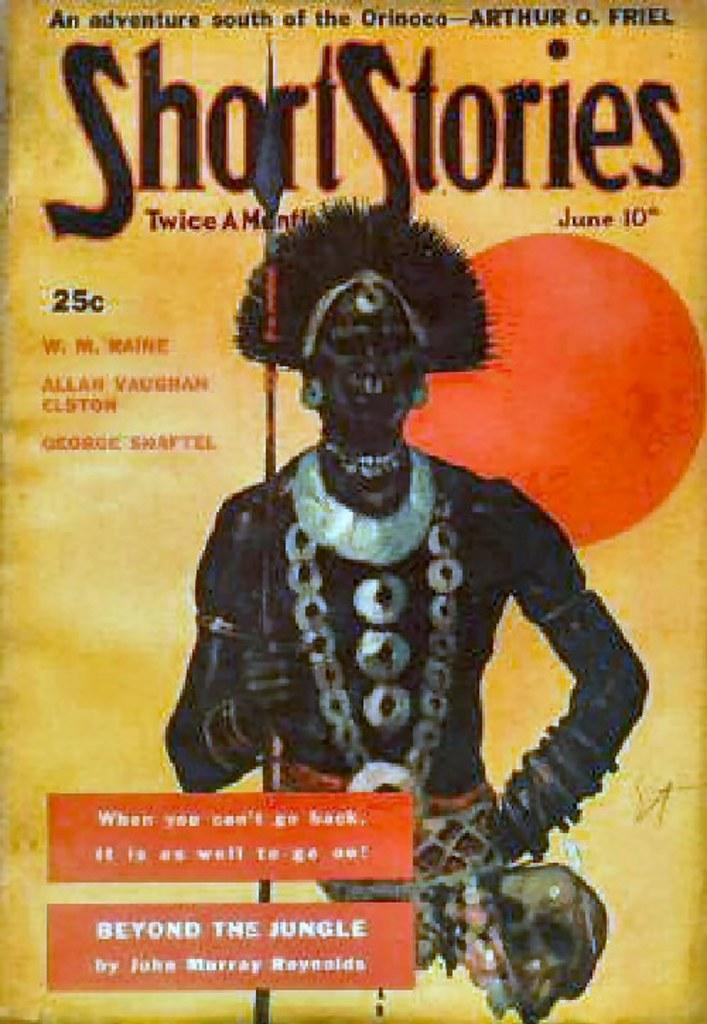What type of visual is the image? The image is a poster. Who is depicted on the poster? There is a man depicted on the poster. What is the man wearing? The man is wearing ornaments. What is the man holding in his hand? The man is holding a tool in his hand. What else can be found on the poster besides the image of the man? There is text on the poster. What type of lace can be seen on the man's clothing in the image? There is no lace visible on the man's clothing in the image. How many steps does the man take in the image? The image is a poster, and there is no action or movement depicted, so it is not possible to determine how many steps the man takes. 